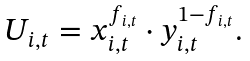<formula> <loc_0><loc_0><loc_500><loc_500>\begin{array} { l } U _ { i , t } = x _ { i , t } ^ { f _ { i , t } } \cdot y _ { i , t } ^ { 1 - f _ { i , t } } . \end{array}</formula> 